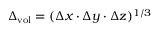<formula> <loc_0><loc_0><loc_500><loc_500>\Delta _ { v o l } = ( \Delta x \cdot \Delta y \cdot \Delta z ) ^ { 1 / 3 }</formula> 